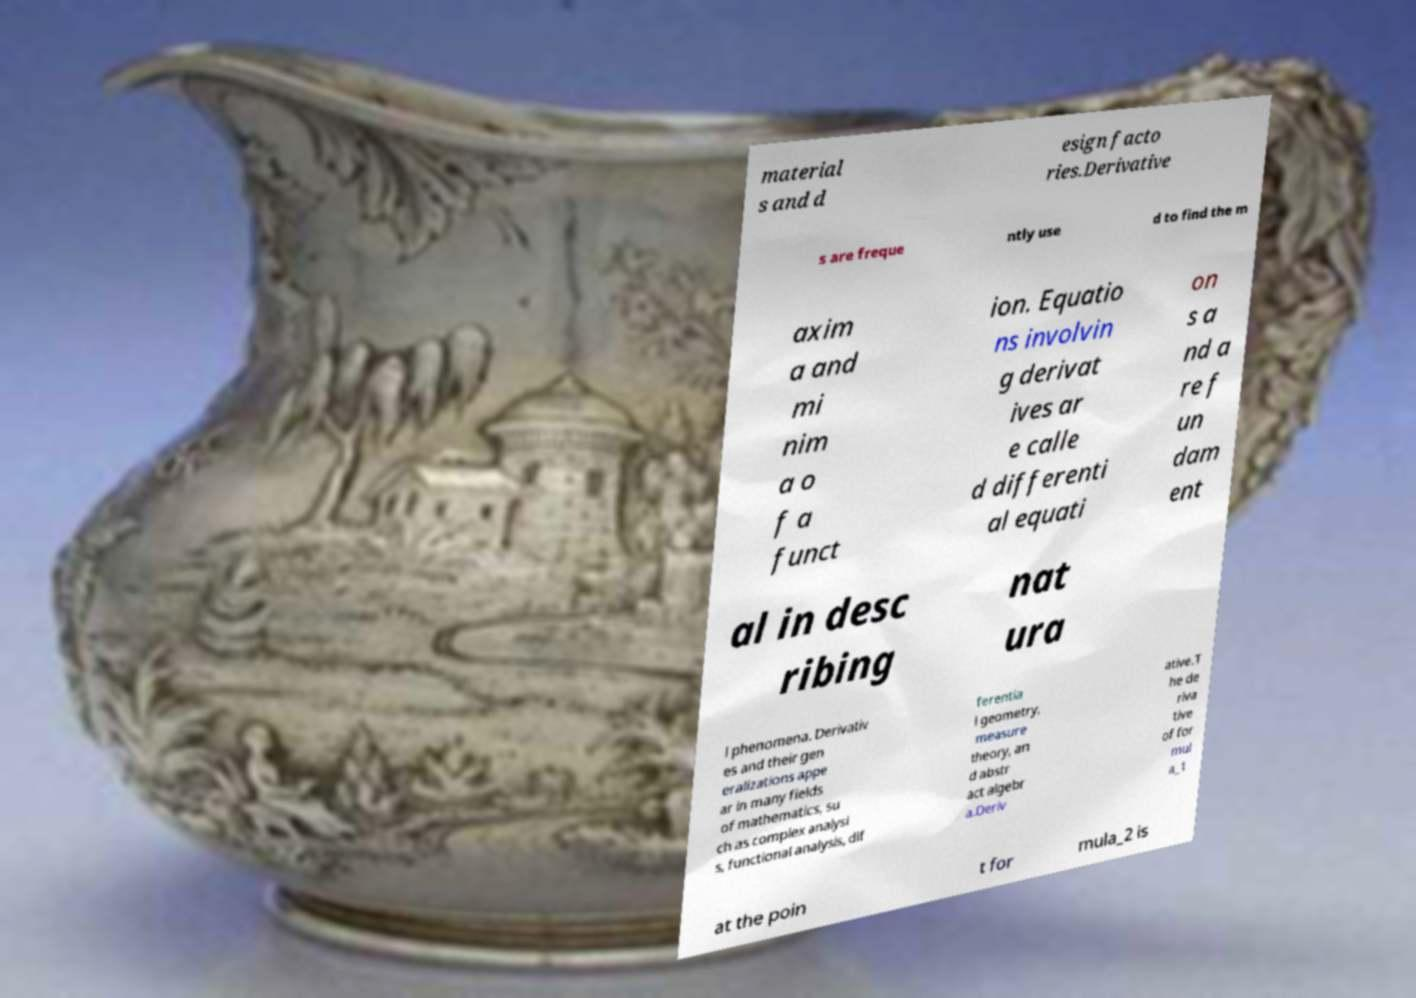What messages or text are displayed in this image? I need them in a readable, typed format. material s and d esign facto ries.Derivative s are freque ntly use d to find the m axim a and mi nim a o f a funct ion. Equatio ns involvin g derivat ives ar e calle d differenti al equati on s a nd a re f un dam ent al in desc ribing nat ura l phenomena. Derivativ es and their gen eralizations appe ar in many fields of mathematics, su ch as complex analysi s, functional analysis, dif ferentia l geometry, measure theory, an d abstr act algebr a.Deriv ative.T he de riva tive of for mul a_1 at the poin t for mula_2 is 